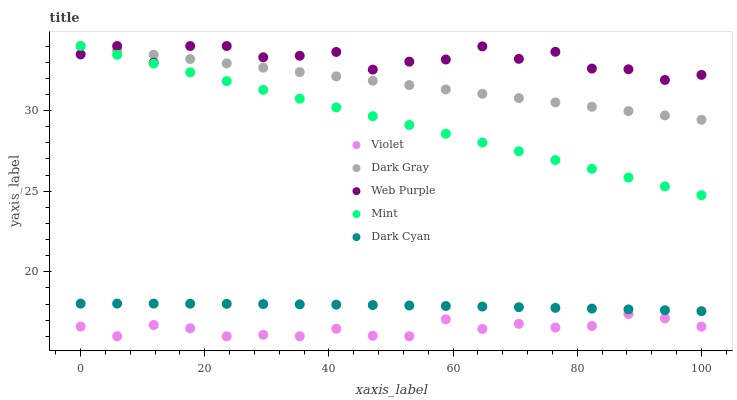Does Violet have the minimum area under the curve?
Answer yes or no. Yes. Does Web Purple have the maximum area under the curve?
Answer yes or no. Yes. Does Dark Cyan have the minimum area under the curve?
Answer yes or no. No. Does Dark Cyan have the maximum area under the curve?
Answer yes or no. No. Is Dark Gray the smoothest?
Answer yes or no. Yes. Is Web Purple the roughest?
Answer yes or no. Yes. Is Dark Cyan the smoothest?
Answer yes or no. No. Is Dark Cyan the roughest?
Answer yes or no. No. Does Violet have the lowest value?
Answer yes or no. Yes. Does Dark Cyan have the lowest value?
Answer yes or no. No. Does Mint have the highest value?
Answer yes or no. Yes. Does Dark Cyan have the highest value?
Answer yes or no. No. Is Dark Cyan less than Mint?
Answer yes or no. Yes. Is Dark Gray greater than Dark Cyan?
Answer yes or no. Yes. Does Mint intersect Dark Gray?
Answer yes or no. Yes. Is Mint less than Dark Gray?
Answer yes or no. No. Is Mint greater than Dark Gray?
Answer yes or no. No. Does Dark Cyan intersect Mint?
Answer yes or no. No. 